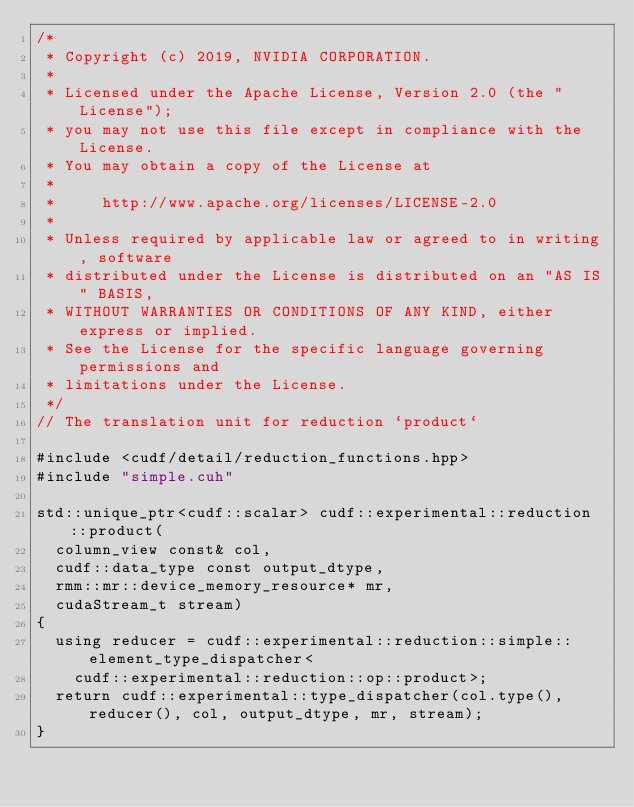<code> <loc_0><loc_0><loc_500><loc_500><_Cuda_>/*
 * Copyright (c) 2019, NVIDIA CORPORATION.
 *
 * Licensed under the Apache License, Version 2.0 (the "License");
 * you may not use this file except in compliance with the License.
 * You may obtain a copy of the License at
 *
 *     http://www.apache.org/licenses/LICENSE-2.0
 *
 * Unless required by applicable law or agreed to in writing, software
 * distributed under the License is distributed on an "AS IS" BASIS,
 * WITHOUT WARRANTIES OR CONDITIONS OF ANY KIND, either express or implied.
 * See the License for the specific language governing permissions and
 * limitations under the License.
 */
// The translation unit for reduction `product`

#include <cudf/detail/reduction_functions.hpp>
#include "simple.cuh"

std::unique_ptr<cudf::scalar> cudf::experimental::reduction::product(
  column_view const& col,
  cudf::data_type const output_dtype,
  rmm::mr::device_memory_resource* mr,
  cudaStream_t stream)
{
  using reducer = cudf::experimental::reduction::simple::element_type_dispatcher<
    cudf::experimental::reduction::op::product>;
  return cudf::experimental::type_dispatcher(col.type(), reducer(), col, output_dtype, mr, stream);
}
</code> 